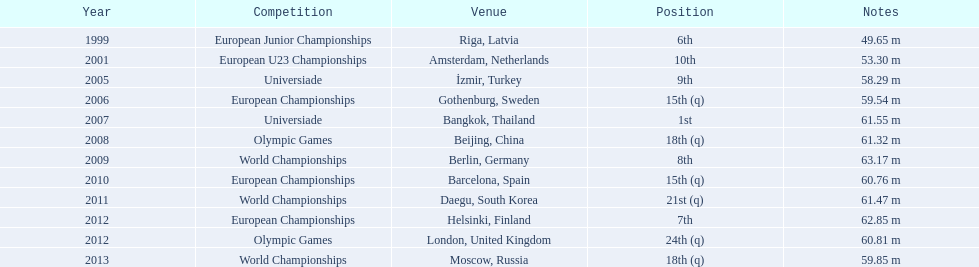What competitions has gerhard mayer been involved in since 1999? European Junior Championships, European U23 Championships, Universiade, European Championships, Universiade, Olympic Games, World Championships, European Championships, World Championships, European Championships, Olympic Games, World Championships. Among them, in which did he accomplish a 60-meter throw or more? Universiade, Olympic Games, World Championships, European Championships, World Championships, European Championships, Olympic Games. Of these throws, which one covered the longest distance? 63.17 m. 